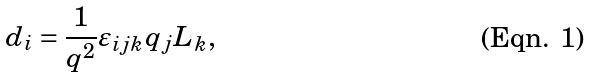Convert formula to latex. <formula><loc_0><loc_0><loc_500><loc_500>d _ { i } = \frac { 1 } { q ^ { 2 } } \varepsilon _ { i j k } q _ { j } L _ { k } ,</formula> 